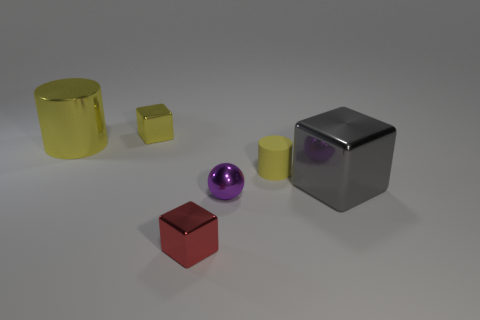What is the size of the cylinder that is the same color as the small rubber object?
Give a very brief answer. Large. Does the tiny cube that is in front of the big gray object have the same material as the small yellow thing behind the big shiny cylinder?
Provide a short and direct response. Yes. Is the number of large shiny things right of the purple sphere the same as the number of large metallic things that are right of the red cube?
Offer a terse response. Yes. How many other small purple spheres are the same material as the purple sphere?
Give a very brief answer. 0. The small metal thing that is the same color as the tiny matte cylinder is what shape?
Offer a terse response. Cube. There is a yellow metal object left of the small shiny cube that is behind the rubber cylinder; what is its size?
Offer a very short reply. Large. Does the yellow object right of the tiny red block have the same shape as the tiny yellow thing behind the rubber cylinder?
Give a very brief answer. No. Is the number of cylinders in front of the tiny cylinder the same as the number of big brown balls?
Offer a very short reply. Yes. What color is the other object that is the same shape as the tiny yellow matte thing?
Provide a succinct answer. Yellow. Does the block behind the large gray thing have the same material as the tiny yellow cylinder?
Your response must be concise. No. 